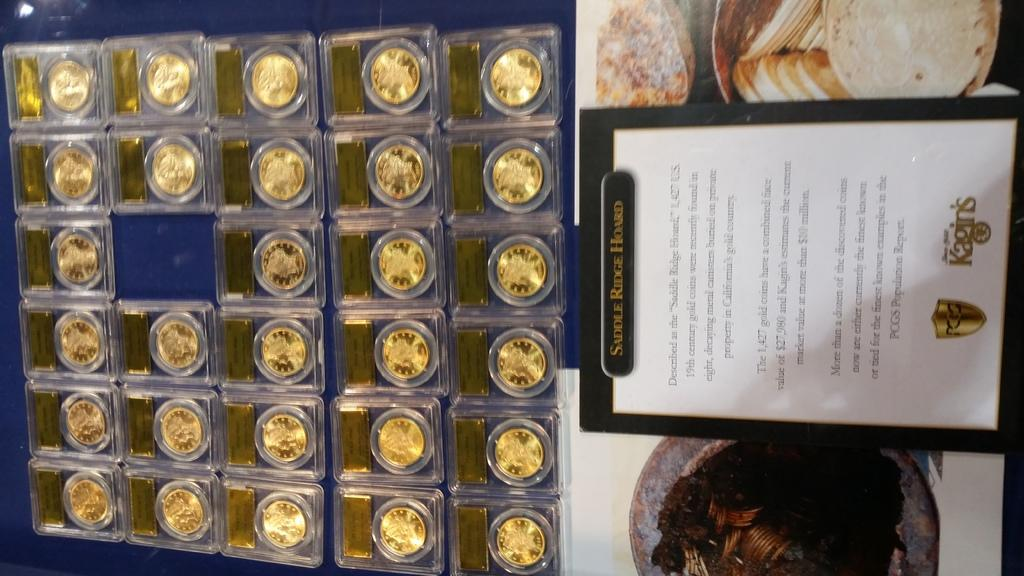<image>
Create a compact narrative representing the image presented. A collection of gold coins complete with the letter of authenticity. 